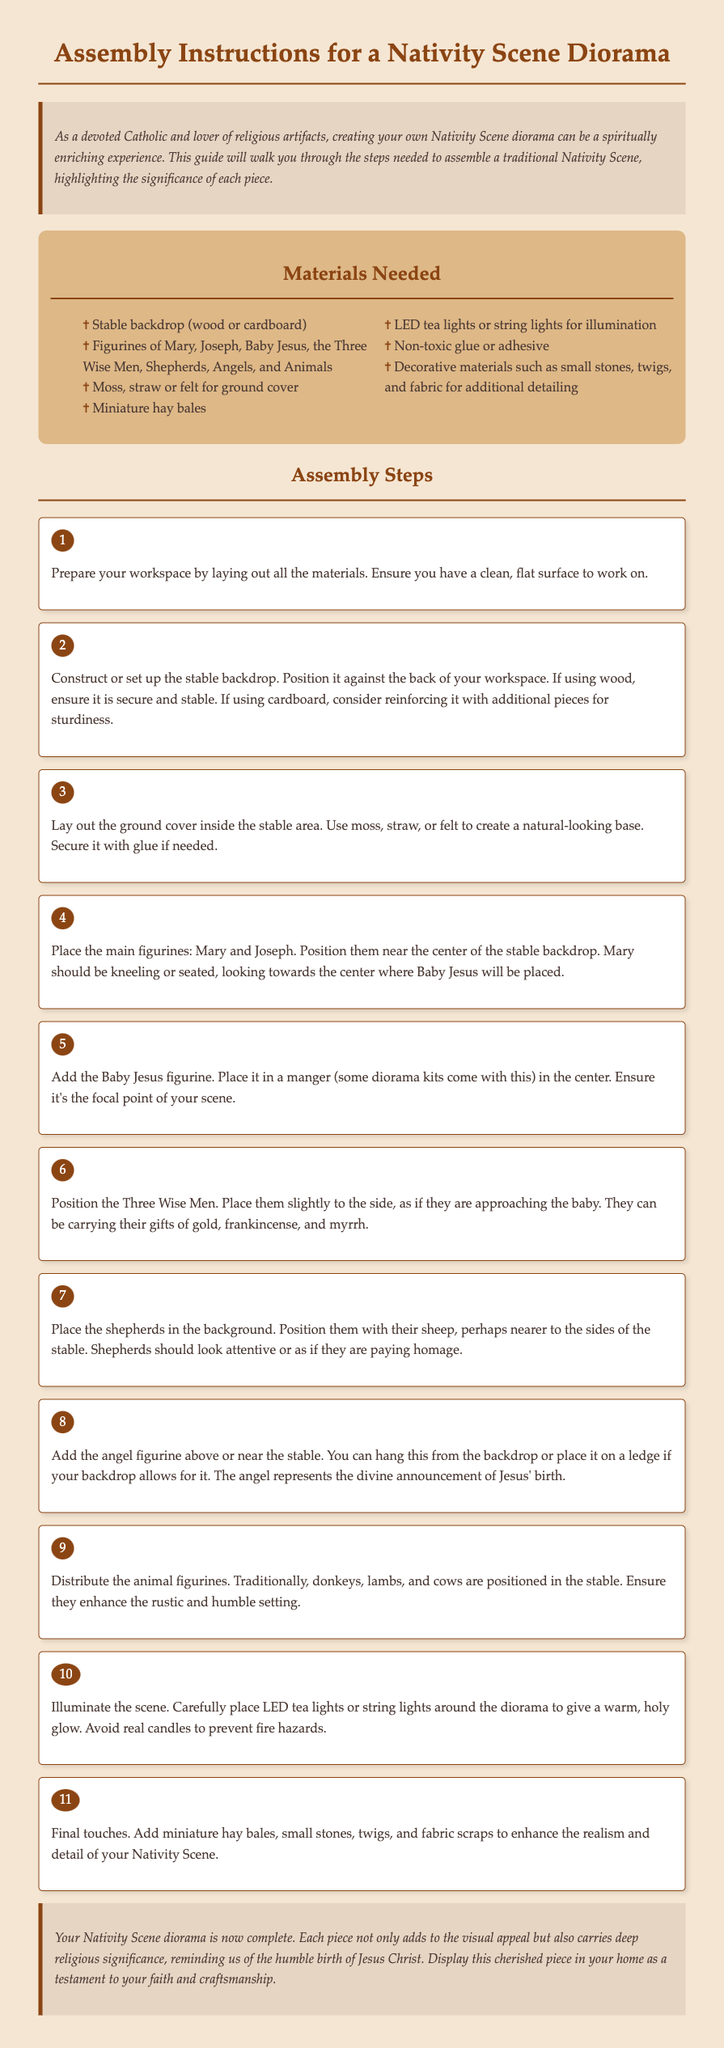What is the title of the document? The title is found in the header section of the document.
Answer: Assembly Instructions for a Nativity Scene Diorama How many figurine types are mentioned? The materials section lists different types of figurines.
Answer: Eight What is the first assembly step? The first step is detailed in the steps section, outlining initial preparation.
Answer: Prepare your workspace What type of lights are recommended for illumination? The assembly steps specify the type of lights to use for the scene.
Answer: LED tea lights What is the significance of the angel figurine? The text describes the role of the angel in the Nativity scene.
Answer: Divine announcement How should Mary be positioned? The description details Mary's positioning in relation to Baby Jesus.
Answer: Near the center Which materials are suggested for ground cover? The materials section lists options for ground coverage in the diorama.
Answer: Moss, straw or felt What should be added for final touches? The last step in the assembly process mentions additional items for detail.
Answer: Miniature hay bales, small stones, twigs, and fabric scraps Where should the Three Wise Men be placed? The assembly steps provide instructions on the positioning of the Wise Men.
Answer: Slightly to the side 